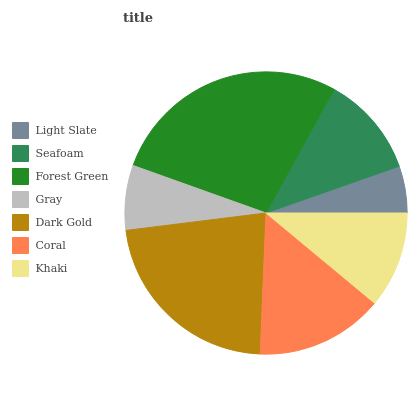Is Light Slate the minimum?
Answer yes or no. Yes. Is Forest Green the maximum?
Answer yes or no. Yes. Is Seafoam the minimum?
Answer yes or no. No. Is Seafoam the maximum?
Answer yes or no. No. Is Seafoam greater than Light Slate?
Answer yes or no. Yes. Is Light Slate less than Seafoam?
Answer yes or no. Yes. Is Light Slate greater than Seafoam?
Answer yes or no. No. Is Seafoam less than Light Slate?
Answer yes or no. No. Is Seafoam the high median?
Answer yes or no. Yes. Is Seafoam the low median?
Answer yes or no. Yes. Is Coral the high median?
Answer yes or no. No. Is Coral the low median?
Answer yes or no. No. 